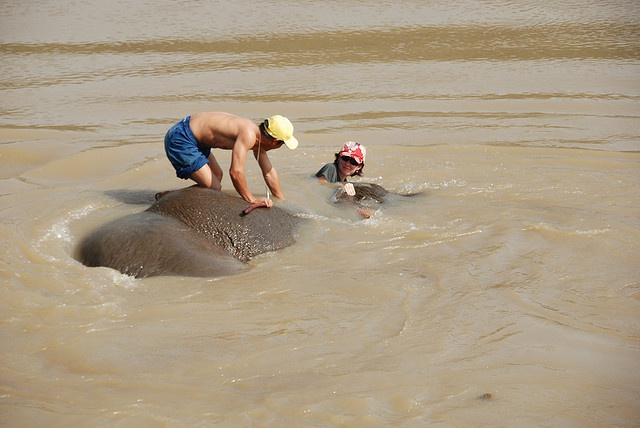Describe the objects in this image and their specific colors. I can see elephant in gray, maroon, and black tones, people in gray, tan, maroon, and black tones, and people in gray, black, lightgray, and maroon tones in this image. 